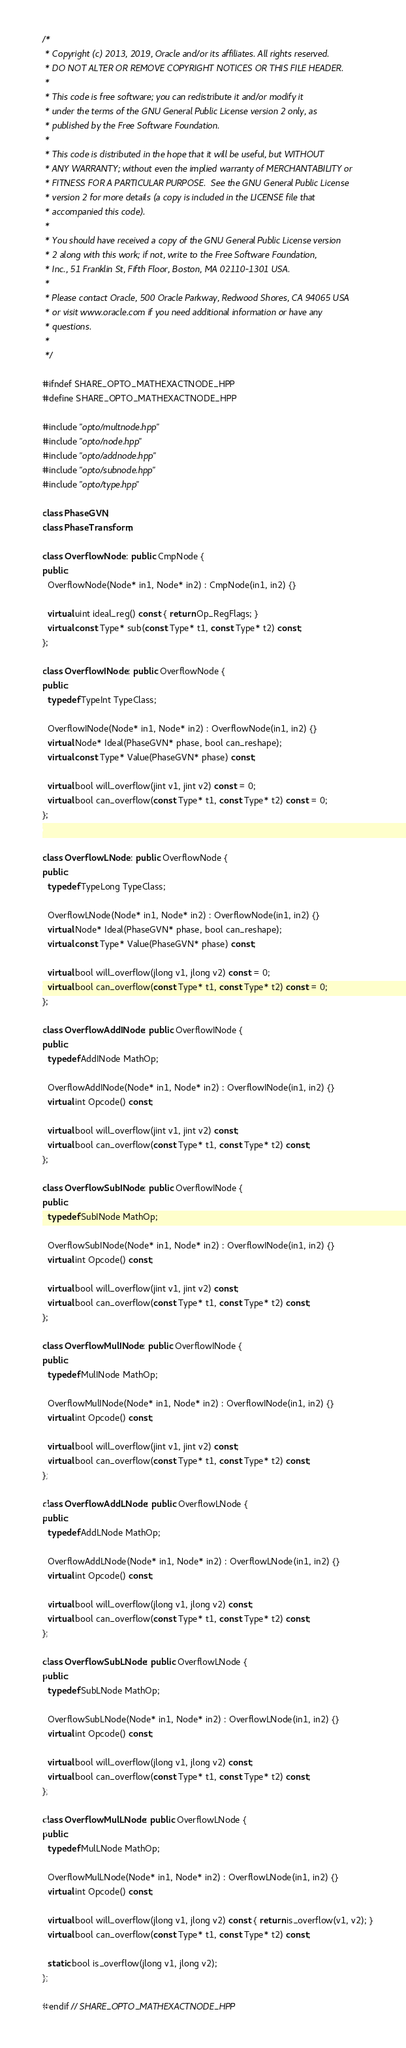<code> <loc_0><loc_0><loc_500><loc_500><_C++_>/*
 * Copyright (c) 2013, 2019, Oracle and/or its affiliates. All rights reserved.
 * DO NOT ALTER OR REMOVE COPYRIGHT NOTICES OR THIS FILE HEADER.
 *
 * This code is free software; you can redistribute it and/or modify it
 * under the terms of the GNU General Public License version 2 only, as
 * published by the Free Software Foundation.
 *
 * This code is distributed in the hope that it will be useful, but WITHOUT
 * ANY WARRANTY; without even the implied warranty of MERCHANTABILITY or
 * FITNESS FOR A PARTICULAR PURPOSE.  See the GNU General Public License
 * version 2 for more details (a copy is included in the LICENSE file that
 * accompanied this code).
 *
 * You should have received a copy of the GNU General Public License version
 * 2 along with this work; if not, write to the Free Software Foundation,
 * Inc., 51 Franklin St, Fifth Floor, Boston, MA 02110-1301 USA.
 *
 * Please contact Oracle, 500 Oracle Parkway, Redwood Shores, CA 94065 USA
 * or visit www.oracle.com if you need additional information or have any
 * questions.
 *
 */

#ifndef SHARE_OPTO_MATHEXACTNODE_HPP
#define SHARE_OPTO_MATHEXACTNODE_HPP

#include "opto/multnode.hpp"
#include "opto/node.hpp"
#include "opto/addnode.hpp"
#include "opto/subnode.hpp"
#include "opto/type.hpp"

class PhaseGVN;
class PhaseTransform;

class OverflowNode : public CmpNode {
public:
  OverflowNode(Node* in1, Node* in2) : CmpNode(in1, in2) {}

  virtual uint ideal_reg() const { return Op_RegFlags; }
  virtual const Type* sub(const Type* t1, const Type* t2) const;
};

class OverflowINode : public OverflowNode {
public:
  typedef TypeInt TypeClass;

  OverflowINode(Node* in1, Node* in2) : OverflowNode(in1, in2) {}
  virtual Node* Ideal(PhaseGVN* phase, bool can_reshape);
  virtual const Type* Value(PhaseGVN* phase) const;

  virtual bool will_overflow(jint v1, jint v2) const = 0;
  virtual bool can_overflow(const Type* t1, const Type* t2) const = 0;
};


class OverflowLNode : public OverflowNode {
public:
  typedef TypeLong TypeClass;

  OverflowLNode(Node* in1, Node* in2) : OverflowNode(in1, in2) {}
  virtual Node* Ideal(PhaseGVN* phase, bool can_reshape);
  virtual const Type* Value(PhaseGVN* phase) const;

  virtual bool will_overflow(jlong v1, jlong v2) const = 0;
  virtual bool can_overflow(const Type* t1, const Type* t2) const = 0;
};

class OverflowAddINode : public OverflowINode {
public:
  typedef AddINode MathOp;

  OverflowAddINode(Node* in1, Node* in2) : OverflowINode(in1, in2) {}
  virtual int Opcode() const;

  virtual bool will_overflow(jint v1, jint v2) const;
  virtual bool can_overflow(const Type* t1, const Type* t2) const;
};

class OverflowSubINode : public OverflowINode {
public:
  typedef SubINode MathOp;

  OverflowSubINode(Node* in1, Node* in2) : OverflowINode(in1, in2) {}
  virtual int Opcode() const;

  virtual bool will_overflow(jint v1, jint v2) const;
  virtual bool can_overflow(const Type* t1, const Type* t2) const;
};

class OverflowMulINode : public OverflowINode {
public:
  typedef MulINode MathOp;

  OverflowMulINode(Node* in1, Node* in2) : OverflowINode(in1, in2) {}
  virtual int Opcode() const;

  virtual bool will_overflow(jint v1, jint v2) const;
  virtual bool can_overflow(const Type* t1, const Type* t2) const;
};

class OverflowAddLNode : public OverflowLNode {
public:
  typedef AddLNode MathOp;

  OverflowAddLNode(Node* in1, Node* in2) : OverflowLNode(in1, in2) {}
  virtual int Opcode() const;

  virtual bool will_overflow(jlong v1, jlong v2) const;
  virtual bool can_overflow(const Type* t1, const Type* t2) const;
};

class OverflowSubLNode : public OverflowLNode {
public:
  typedef SubLNode MathOp;

  OverflowSubLNode(Node* in1, Node* in2) : OverflowLNode(in1, in2) {}
  virtual int Opcode() const;

  virtual bool will_overflow(jlong v1, jlong v2) const;
  virtual bool can_overflow(const Type* t1, const Type* t2) const;
};

class OverflowMulLNode : public OverflowLNode {
public:
  typedef MulLNode MathOp;

  OverflowMulLNode(Node* in1, Node* in2) : OverflowLNode(in1, in2) {}
  virtual int Opcode() const;

  virtual bool will_overflow(jlong v1, jlong v2) const { return is_overflow(v1, v2); }
  virtual bool can_overflow(const Type* t1, const Type* t2) const;

  static bool is_overflow(jlong v1, jlong v2);
};

#endif // SHARE_OPTO_MATHEXACTNODE_HPP
</code> 